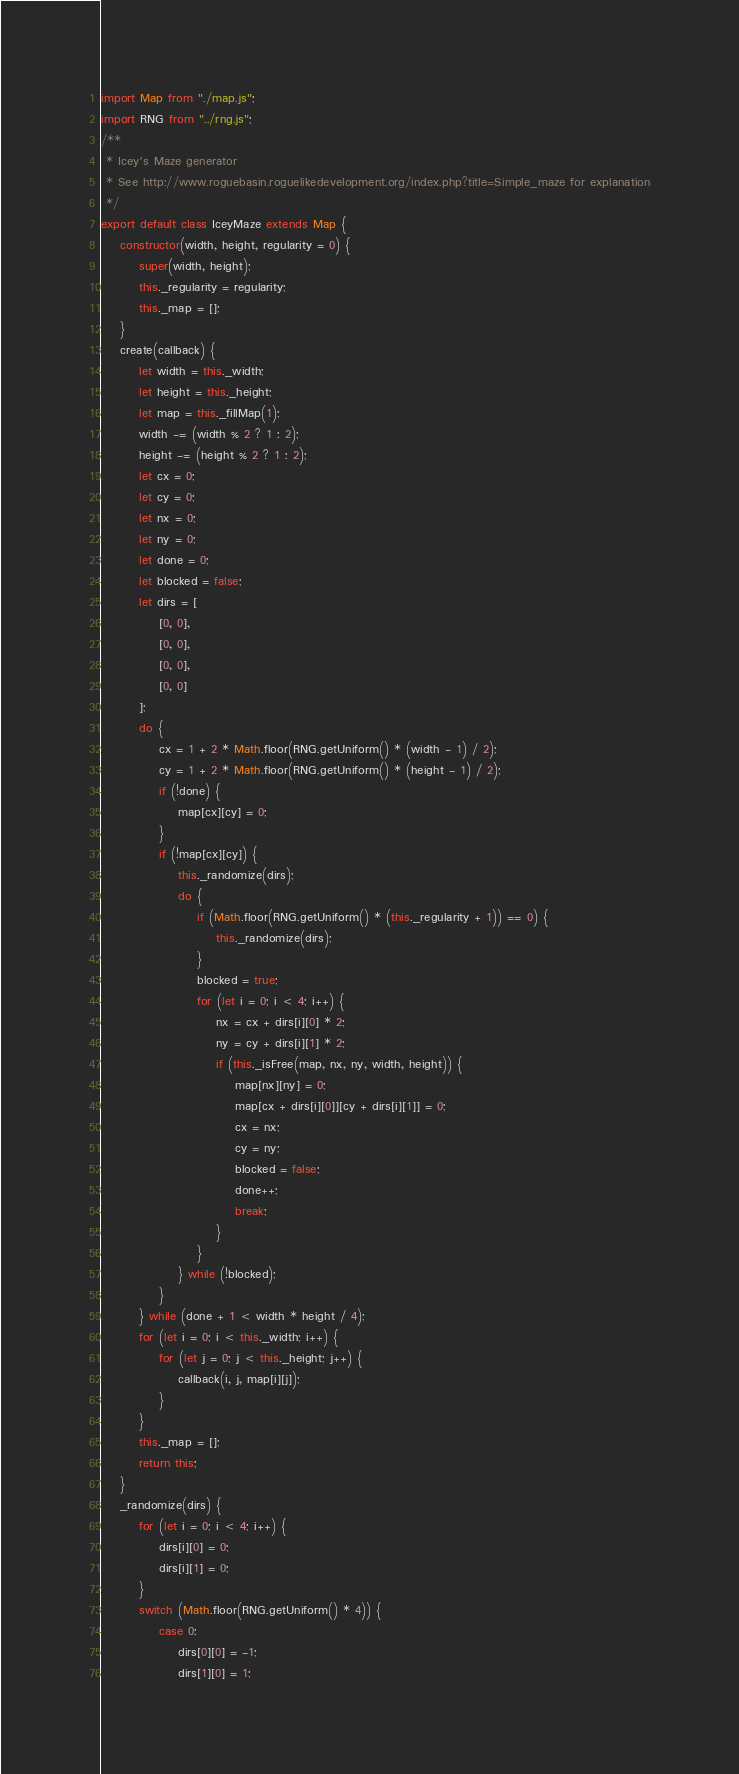<code> <loc_0><loc_0><loc_500><loc_500><_JavaScript_>import Map from "./map.js";
import RNG from "../rng.js";
/**
 * Icey's Maze generator
 * See http://www.roguebasin.roguelikedevelopment.org/index.php?title=Simple_maze for explanation
 */
export default class IceyMaze extends Map {
    constructor(width, height, regularity = 0) {
        super(width, height);
        this._regularity = regularity;
        this._map = [];
    }
    create(callback) {
        let width = this._width;
        let height = this._height;
        let map = this._fillMap(1);
        width -= (width % 2 ? 1 : 2);
        height -= (height % 2 ? 1 : 2);
        let cx = 0;
        let cy = 0;
        let nx = 0;
        let ny = 0;
        let done = 0;
        let blocked = false;
        let dirs = [
            [0, 0],
            [0, 0],
            [0, 0],
            [0, 0]
        ];
        do {
            cx = 1 + 2 * Math.floor(RNG.getUniform() * (width - 1) / 2);
            cy = 1 + 2 * Math.floor(RNG.getUniform() * (height - 1) / 2);
            if (!done) {
                map[cx][cy] = 0;
            }
            if (!map[cx][cy]) {
                this._randomize(dirs);
                do {
                    if (Math.floor(RNG.getUniform() * (this._regularity + 1)) == 0) {
                        this._randomize(dirs);
                    }
                    blocked = true;
                    for (let i = 0; i < 4; i++) {
                        nx = cx + dirs[i][0] * 2;
                        ny = cy + dirs[i][1] * 2;
                        if (this._isFree(map, nx, ny, width, height)) {
                            map[nx][ny] = 0;
                            map[cx + dirs[i][0]][cy + dirs[i][1]] = 0;
                            cx = nx;
                            cy = ny;
                            blocked = false;
                            done++;
                            break;
                        }
                    }
                } while (!blocked);
            }
        } while (done + 1 < width * height / 4);
        for (let i = 0; i < this._width; i++) {
            for (let j = 0; j < this._height; j++) {
                callback(i, j, map[i][j]);
            }
        }
        this._map = [];
        return this;
    }
    _randomize(dirs) {
        for (let i = 0; i < 4; i++) {
            dirs[i][0] = 0;
            dirs[i][1] = 0;
        }
        switch (Math.floor(RNG.getUniform() * 4)) {
            case 0:
                dirs[0][0] = -1;
                dirs[1][0] = 1;</code> 